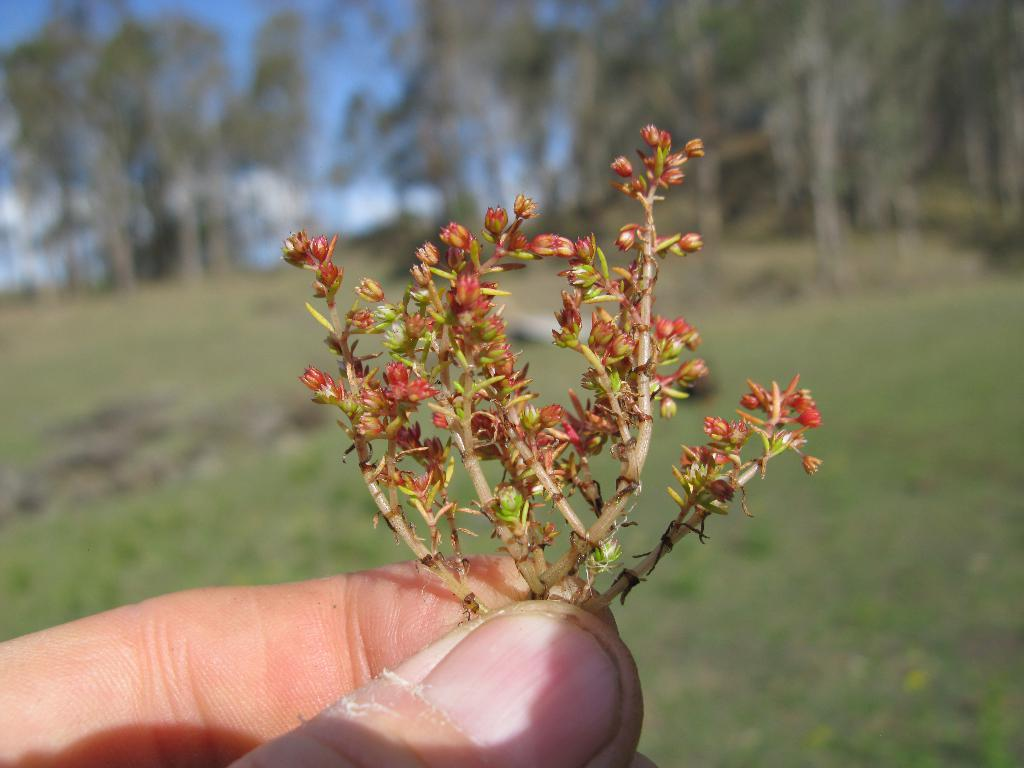What type of plant is visible in the image? There are small flower buds in the image. Who or what is holding the flower buds? A human hand is holding the flower buds. What type of vegetation is on the ground in the image? There is grass on the ground in the image. What can be seen in the background of the image? There are trees and the sky visible in the background of the image. What color are the eyes of the person wearing the crown in the image? There is no person wearing a crown present in the image. 